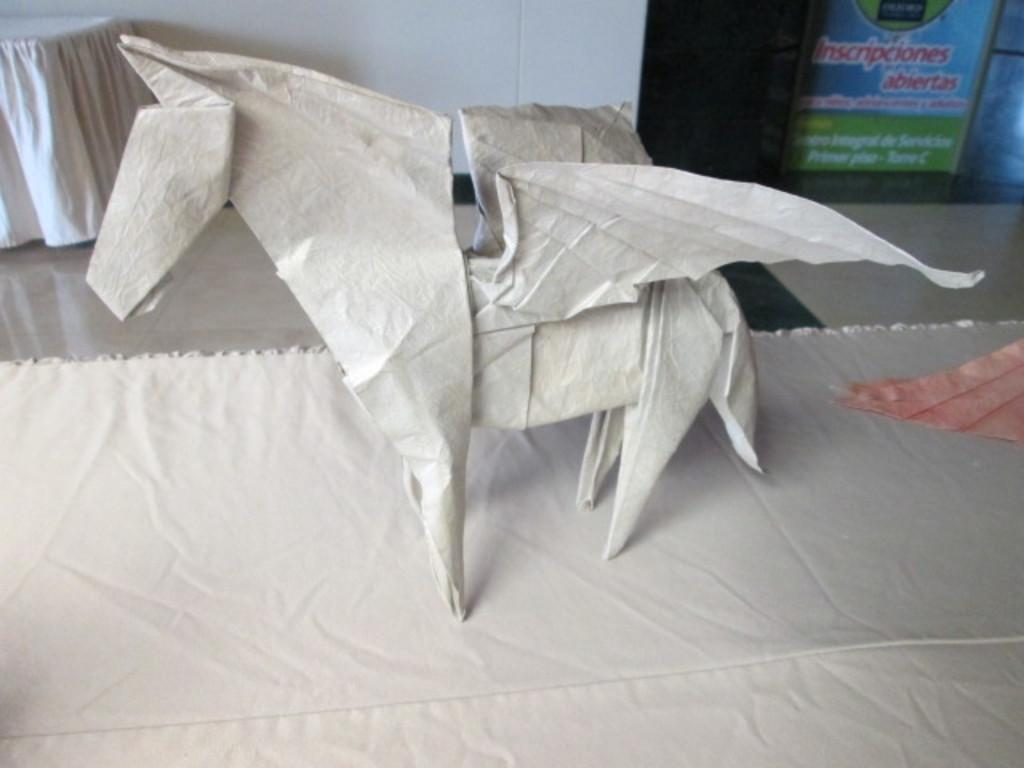What is the main subject of the image? The main subject of the image is a statue of a horse. What material is the statue made of? The statue is made with paper. Where is the statue placed in the image? The statue is kept on the ground. How many branches can be seen growing from the horse's back in the image? There are no branches visible on the horse's back in the image, as it is a statue made of paper. Is there a goat present in the image? No, there is no goat present in the image; it features a statue of a horse. 